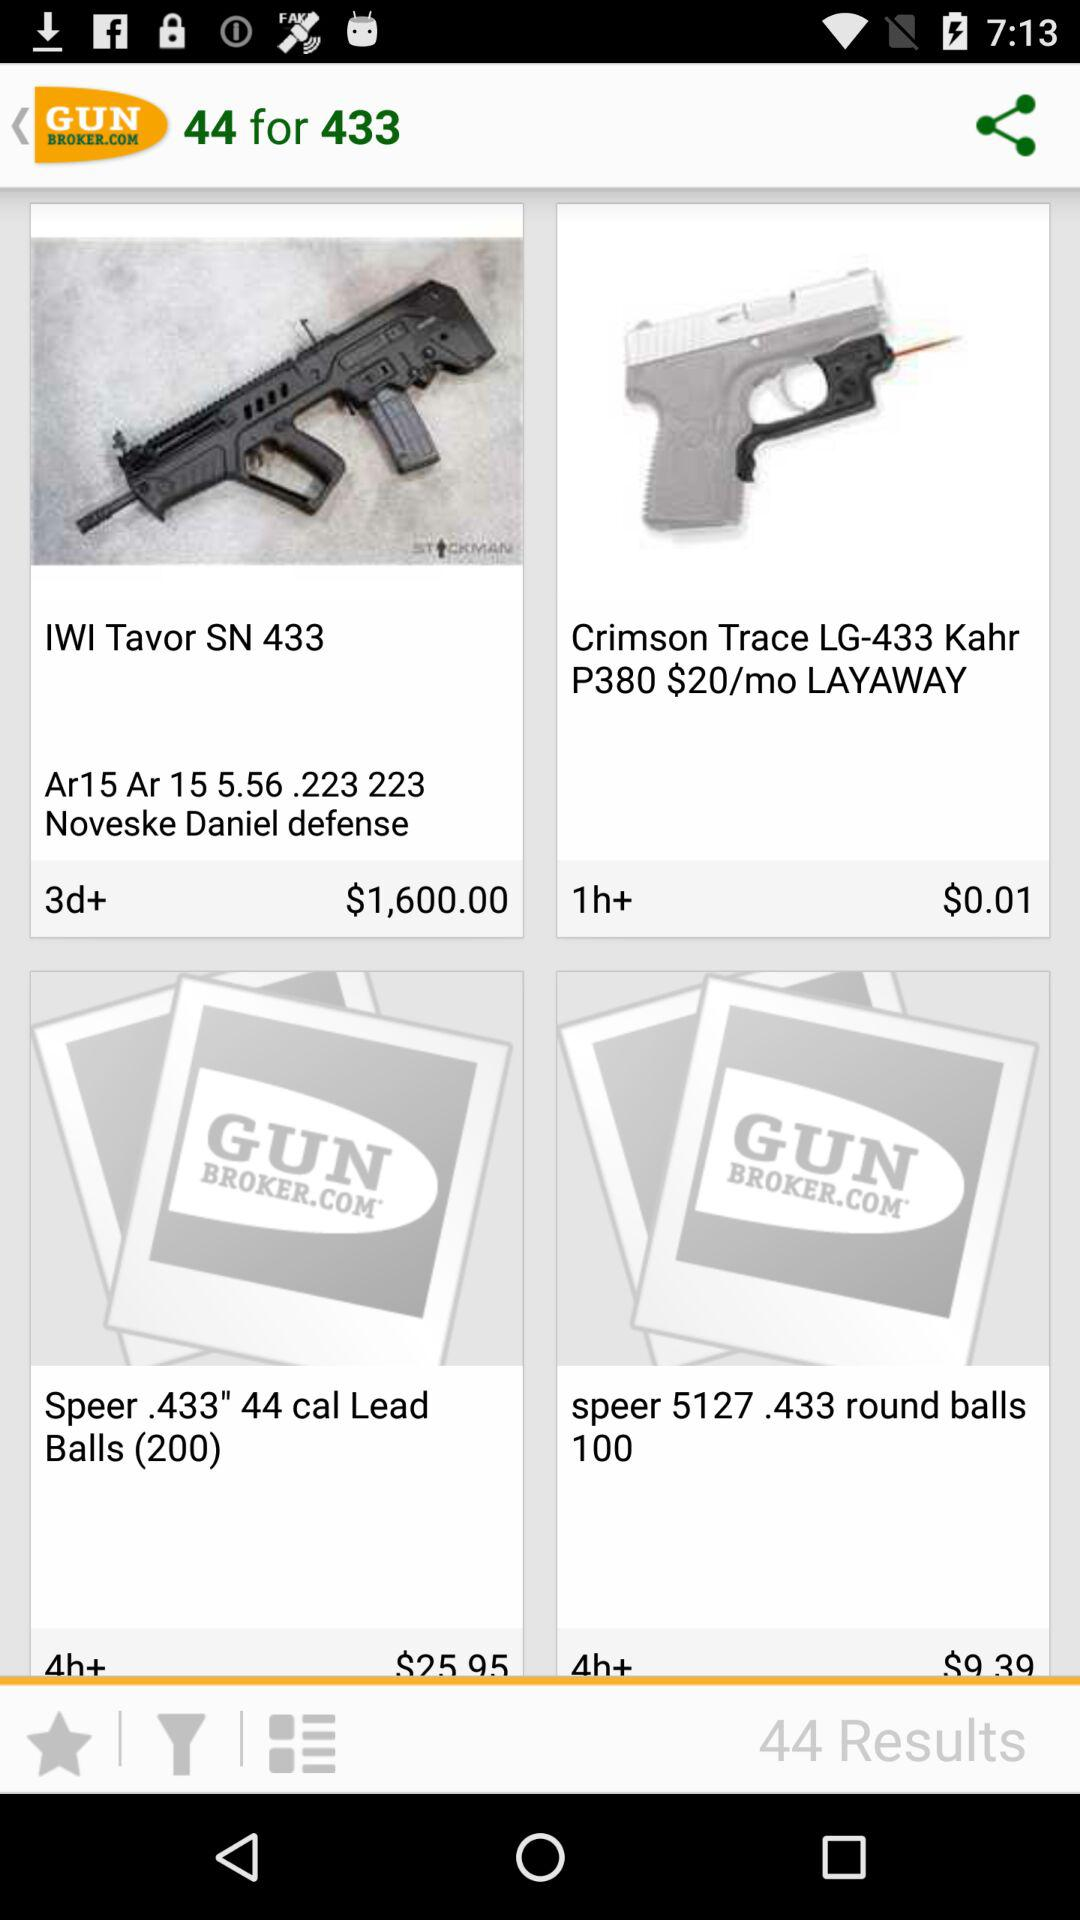What is the name of the application? The name of the application is "GUN BROKER.COM". 